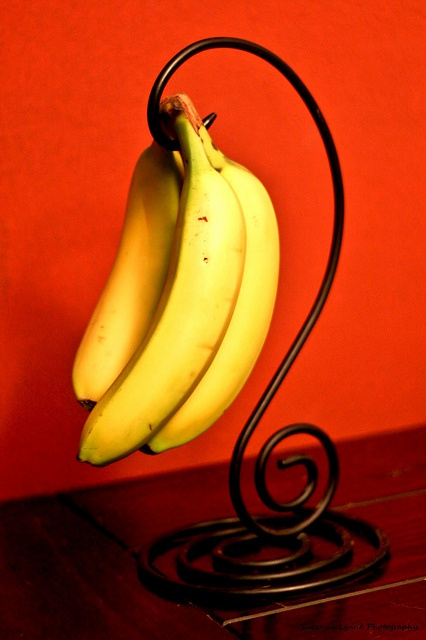Describe the objects in this image and their specific colors. I can see a banana in red, gold, orange, and olive tones in this image. 